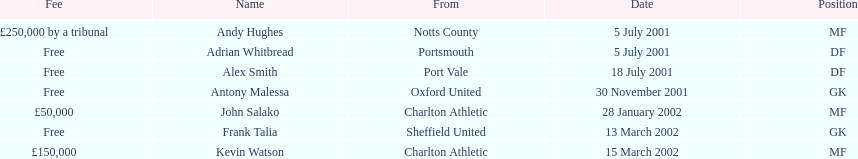Whos name is listed last on the chart? Kevin Watson. 